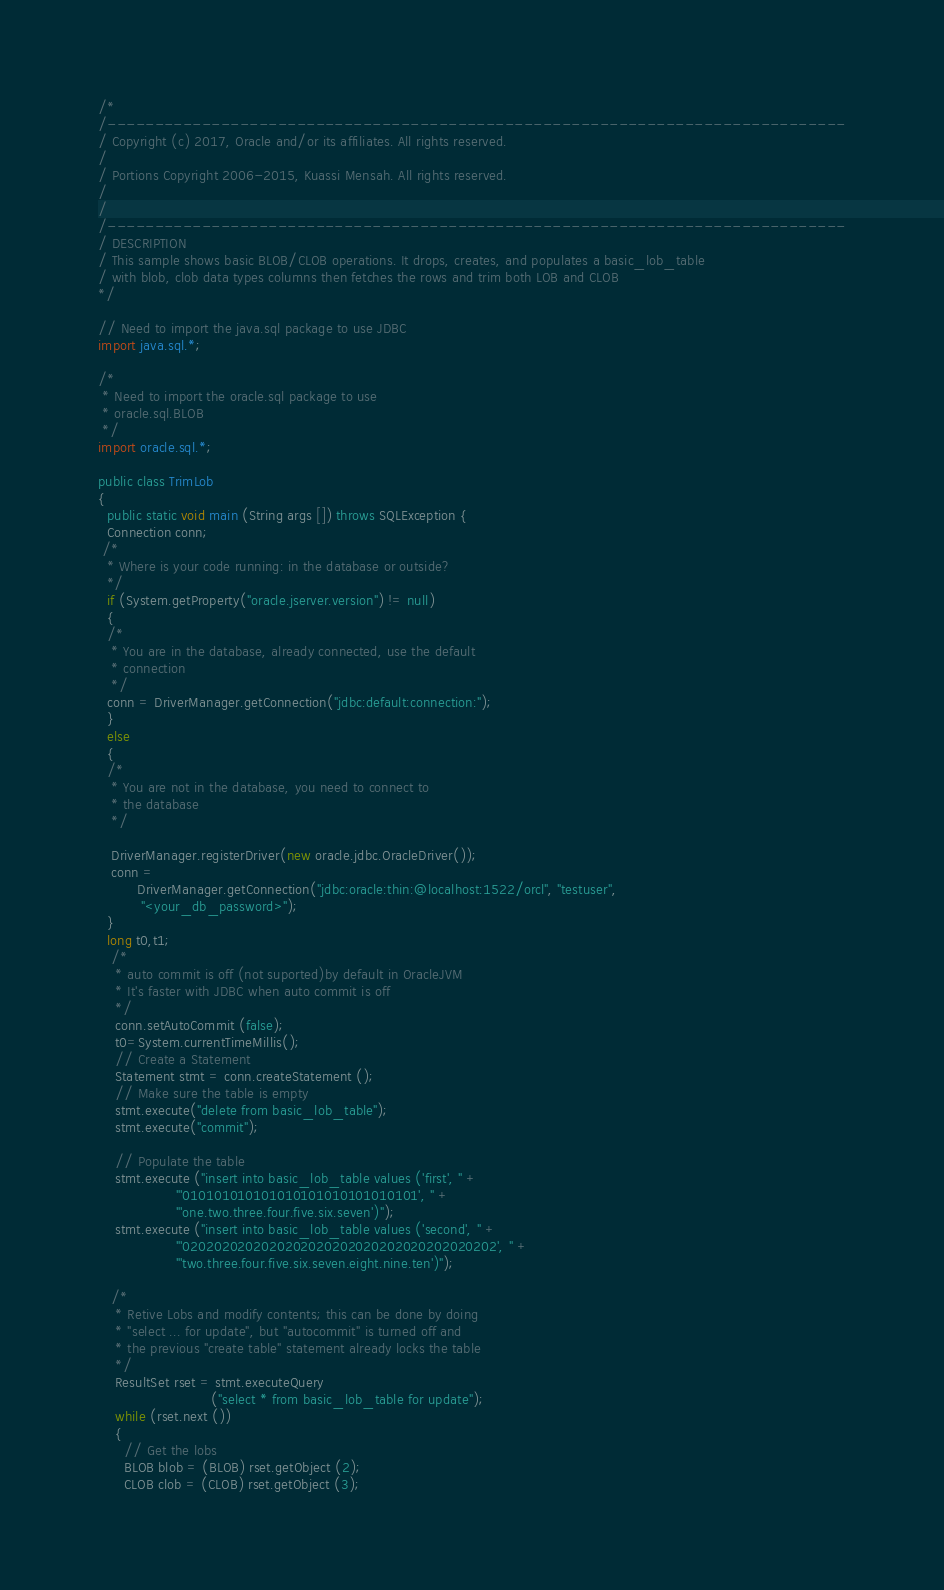<code> <loc_0><loc_0><loc_500><loc_500><_Java_>/*
/------------------------------------------------------------------------------
/ Copyright (c) 2017, Oracle and/or its affiliates. All rights reserved.
/
/ Portions Copyright 2006-2015, Kuassi Mensah. All rights reserved.
/
/
/------------------------------------------------------------------------------
/ DESCRIPTION
/ This sample shows basic BLOB/CLOB operations. It drops, creates, and populates a basic_lob_table
/ with blob, clob data types columns then fetches the rows and trim both LOB and CLOB
*/

// Need to import the java.sql package to use JDBC
import java.sql.*;

/* 
 * Need to import the oracle.sql package to use 
 * oracle.sql.BLOB
 */
import oracle.sql.*;

public class TrimLob
{
  public static void main (String args []) throws SQLException {
  Connection conn;
 /*
  * Where is your code running: in the database or outside?
  */
  if (System.getProperty("oracle.jserver.version") != null)
  {
  /* 
   * You are in the database, already connected, use the default 
   * connection
   */
  conn = DriverManager.getConnection("jdbc:default:connection:");
  }
  else
  {
  /* 
   * You are not in the database, you need to connect to 
   * the database
   */

   DriverManager.registerDriver(new oracle.jdbc.OracleDriver());  
   conn = 
         DriverManager.getConnection("jdbc:oracle:thin:@localhost:1522/orcl", "testuser",
          "<your_db_password>");
  }
  long t0,t1;
   /* 
    * auto commit is off (not suported)by default in OracleJVM
    * It's faster with JDBC when auto commit is off
    */
    conn.setAutoCommit (false);
    t0=System.currentTimeMillis(); 
    // Create a Statement
    Statement stmt = conn.createStatement ();
    // Make sure the table is empty
    stmt.execute("delete from basic_lob_table");
    stmt.execute("commit"); 

    // Populate the table
    stmt.execute ("insert into basic_lob_table values ('first', " +
                  "'010101010101010101010101010101', " +
                  "'one.two.three.four.five.six.seven')");
    stmt.execute ("insert into basic_lob_table values ('second', " +
                  "'0202020202020202020202020202020202020202', " +
                  "'two.three.four.five.six.seven.eight.nine.ten')");
    
   /* 
    * Retive Lobs and modify contents; this can be done by doing
    * "select ... for update", but "autocommit" is turned off and
    * the previous "create table" statement already locks the table 
    */
    ResultSet rset = stmt.executeQuery
                          ("select * from basic_lob_table for update");                   
    while (rset.next ())
    {
      // Get the lobs
      BLOB blob = (BLOB) rset.getObject (2);
      CLOB clob = (CLOB) rset.getObject (3);
</code> 